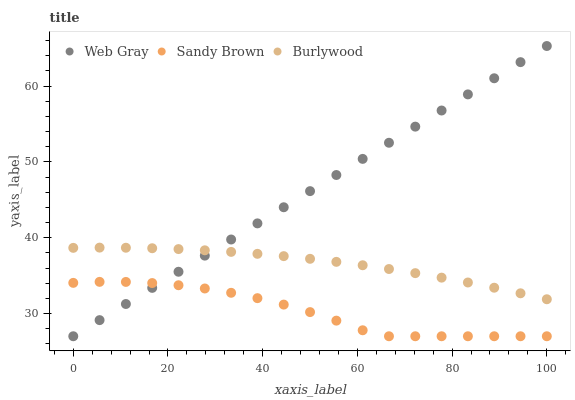Does Sandy Brown have the minimum area under the curve?
Answer yes or no. Yes. Does Web Gray have the maximum area under the curve?
Answer yes or no. Yes. Does Web Gray have the minimum area under the curve?
Answer yes or no. No. Does Sandy Brown have the maximum area under the curve?
Answer yes or no. No. Is Web Gray the smoothest?
Answer yes or no. Yes. Is Sandy Brown the roughest?
Answer yes or no. Yes. Is Sandy Brown the smoothest?
Answer yes or no. No. Is Web Gray the roughest?
Answer yes or no. No. Does Web Gray have the lowest value?
Answer yes or no. Yes. Does Web Gray have the highest value?
Answer yes or no. Yes. Does Sandy Brown have the highest value?
Answer yes or no. No. Is Sandy Brown less than Burlywood?
Answer yes or no. Yes. Is Burlywood greater than Sandy Brown?
Answer yes or no. Yes. Does Web Gray intersect Sandy Brown?
Answer yes or no. Yes. Is Web Gray less than Sandy Brown?
Answer yes or no. No. Is Web Gray greater than Sandy Brown?
Answer yes or no. No. Does Sandy Brown intersect Burlywood?
Answer yes or no. No. 